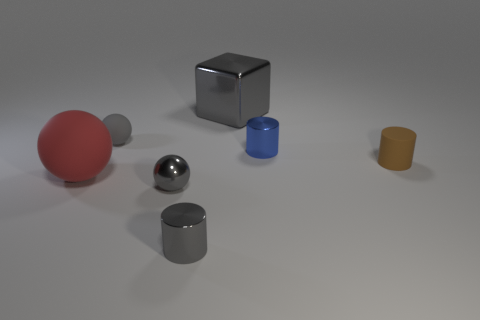Subtract 1 cylinders. How many cylinders are left? 2 Subtract all brown matte cylinders. How many cylinders are left? 2 Add 3 red matte spheres. How many objects exist? 10 Subtract all spheres. How many objects are left? 4 Subtract all blue objects. Subtract all small spheres. How many objects are left? 4 Add 7 small gray matte spheres. How many small gray matte spheres are left? 8 Add 6 brown cylinders. How many brown cylinders exist? 7 Subtract 1 blue cylinders. How many objects are left? 6 